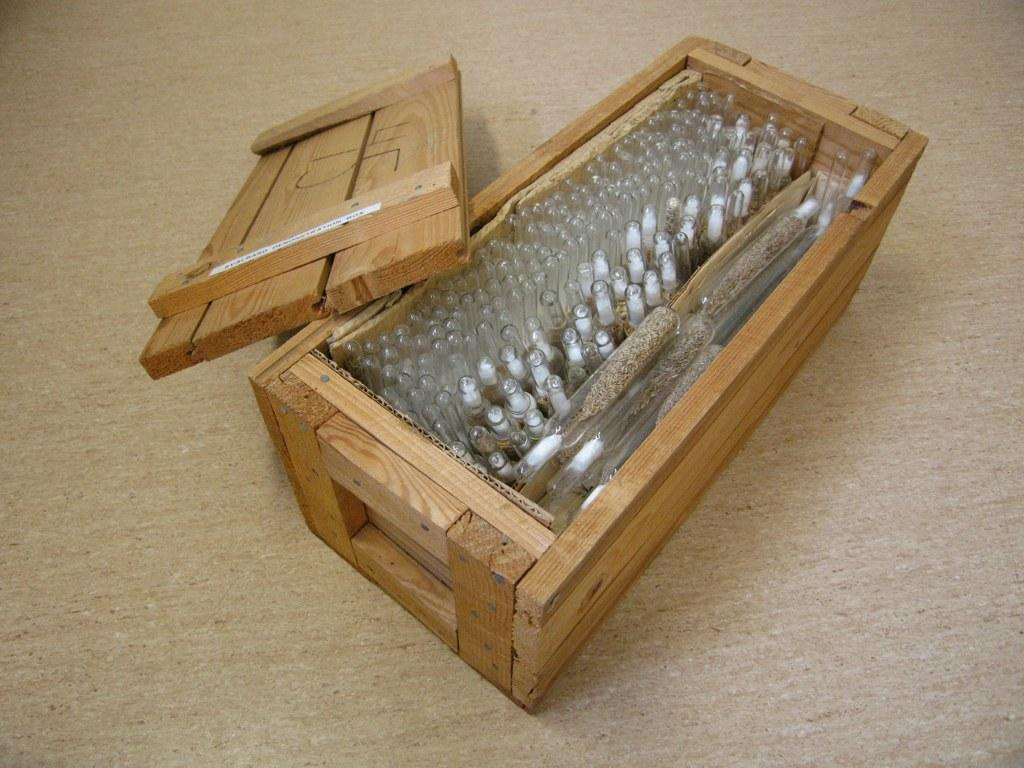What type of container is present in the image? There is a wooden box in the image. What is inside the wooden box? There are bottles inside the wooden box. What other object can be seen in the image? There is a board in the image. What is visible at the bottom of the image? The floor is visible at the bottom of the image. What type of lock is on the wooden box in the image? There is no lock visible on the wooden box in the image. Can you describe the clouds in the image? There are no clouds present in the image. 